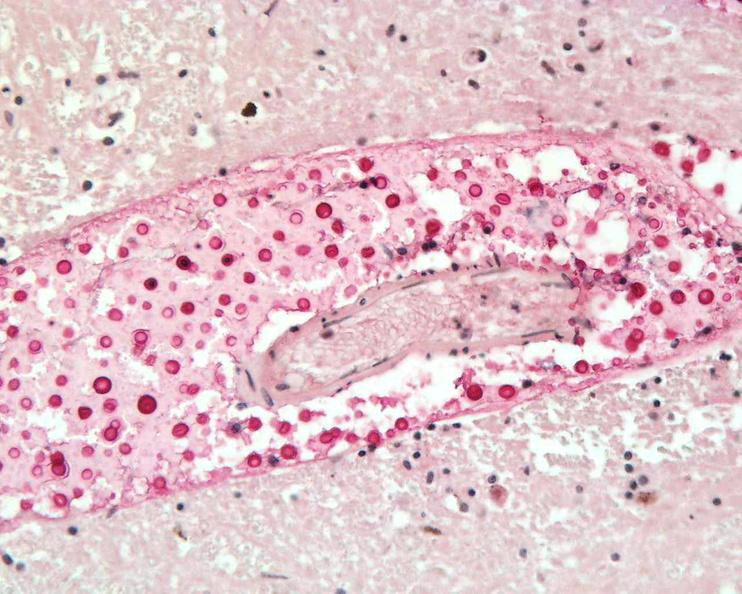do sacrococcygeal teratoma stain?
Answer the question using a single word or phrase. No 